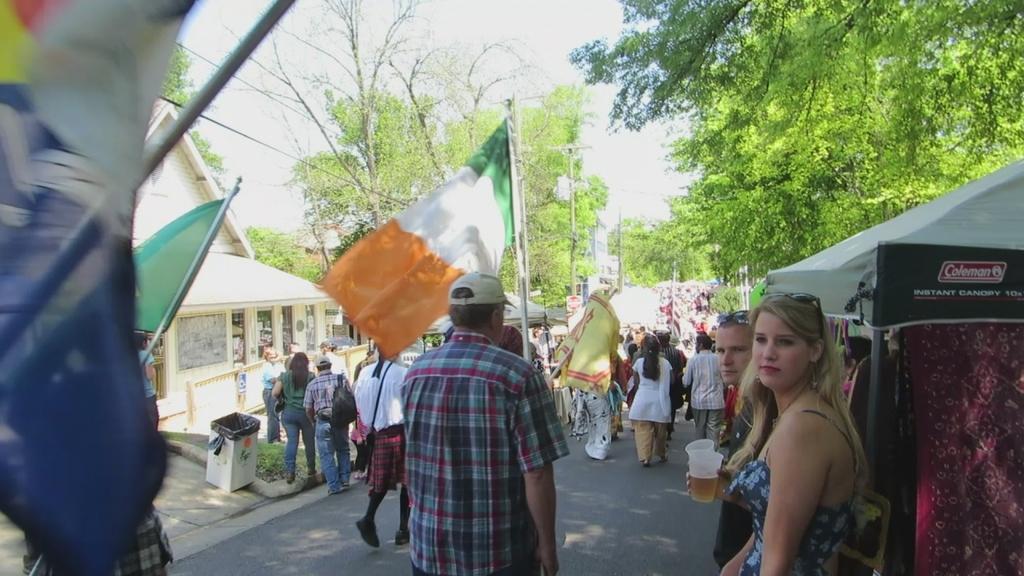Please provide a concise description of this image. In this image we can see few people on the road, some of them are holding flags, two person standing near the stall and holding glasses with drink, there are few trees, buildings, wires and the sky in the background. 